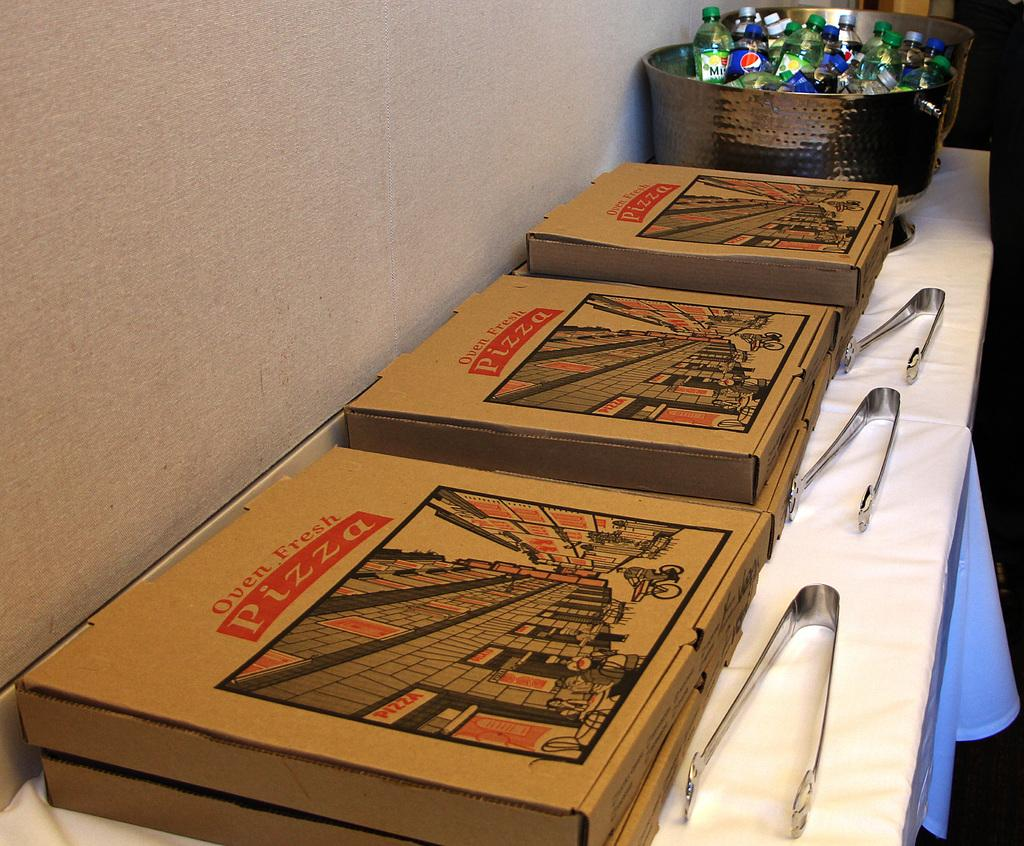<image>
Describe the image concisely. several Oven Fresh Pizza boxes are lined up on a banquet table 